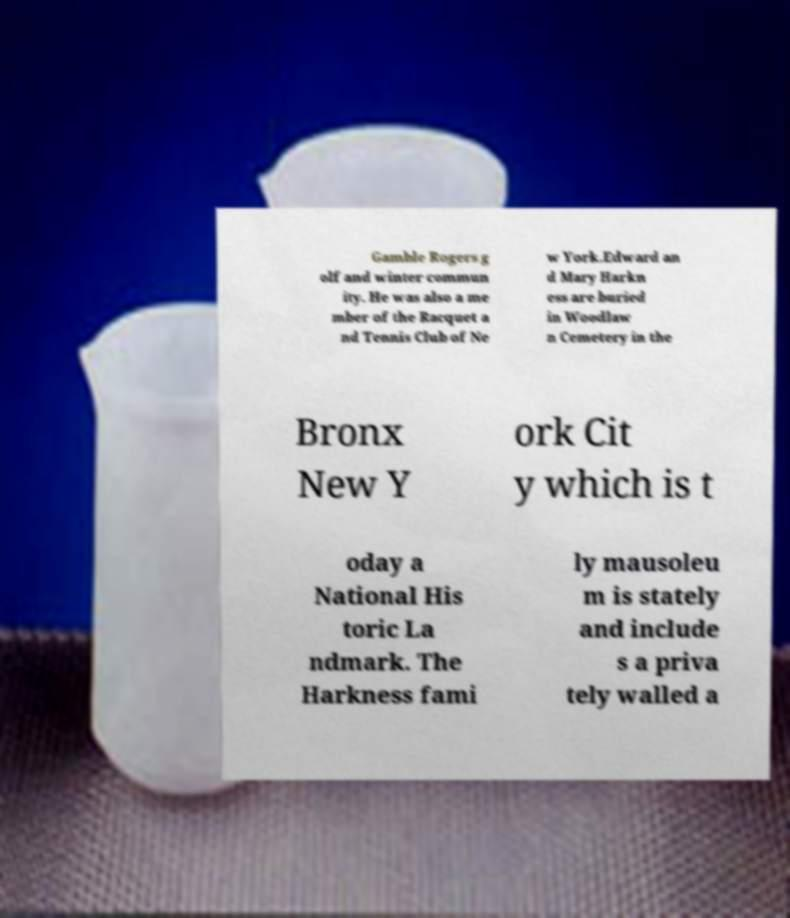Please read and relay the text visible in this image. What does it say? Gamble Rogers g olf and winter commun ity. He was also a me mber of the Racquet a nd Tennis Club of Ne w York.Edward an d Mary Harkn ess are buried in Woodlaw n Cemetery in the Bronx New Y ork Cit y which is t oday a National His toric La ndmark. The Harkness fami ly mausoleu m is stately and include s a priva tely walled a 